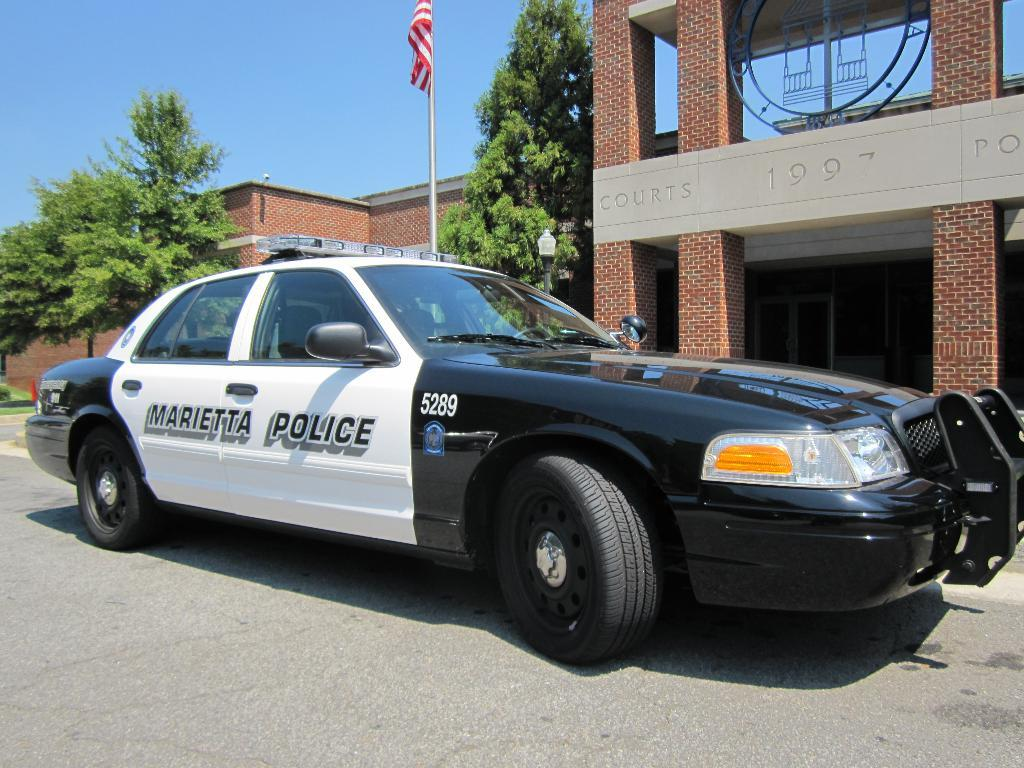<image>
Relay a brief, clear account of the picture shown. A Marietta police car in front of a brick building. 